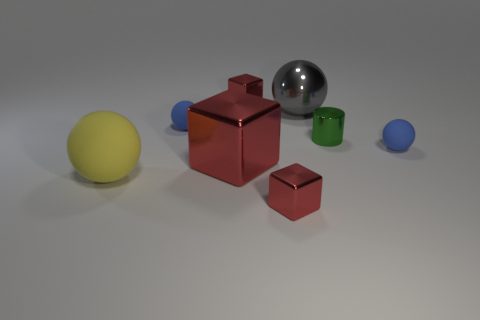How many red cubes must be subtracted to get 1 red cubes? 2 Add 1 cyan things. How many objects exist? 9 Subtract all cylinders. How many objects are left? 7 Add 4 large red metallic objects. How many large red metallic objects exist? 5 Subtract 0 red spheres. How many objects are left? 8 Subtract all big gray metal things. Subtract all small green cylinders. How many objects are left? 6 Add 3 small cylinders. How many small cylinders are left? 4 